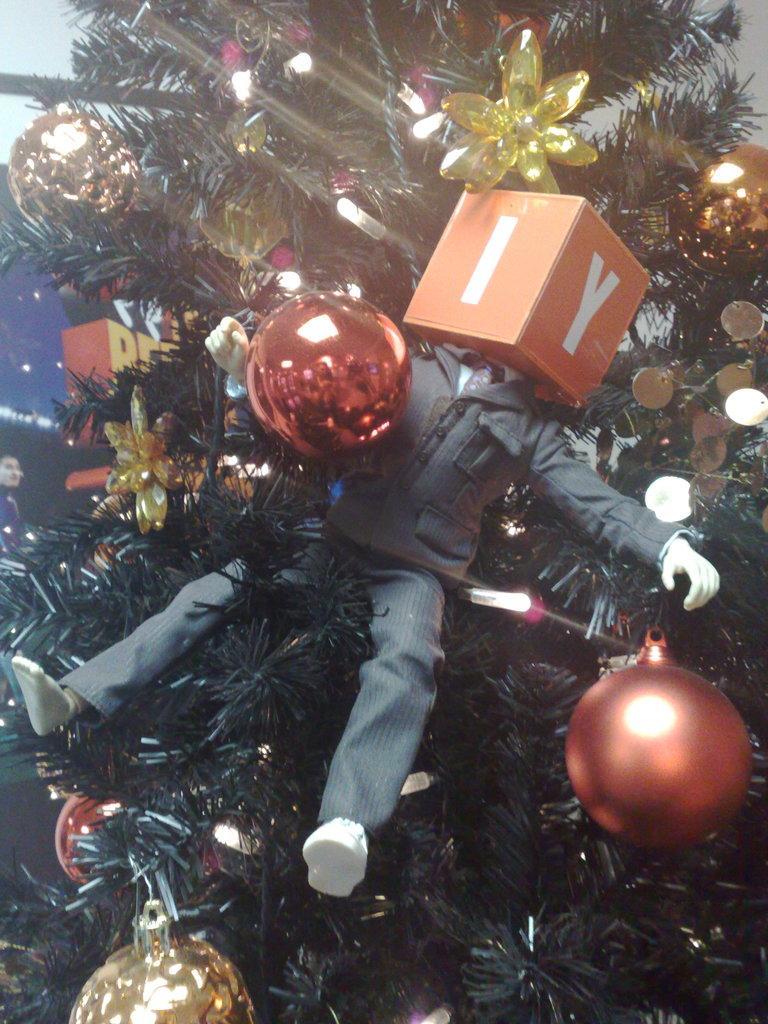Please provide a concise description of this image. In this picture we can see a tree is decorated with lights, some objects and a toy. On the left side of the image, there is a person. 